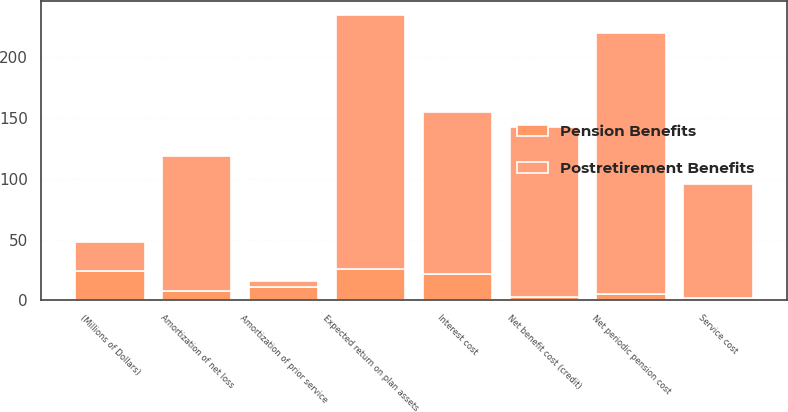Convert chart to OTSL. <chart><loc_0><loc_0><loc_500><loc_500><stacked_bar_chart><ecel><fcel>(Millions of Dollars)<fcel>Service cost<fcel>Interest cost<fcel>Expected return on plan assets<fcel>Amortization of prior service<fcel>Amortization of net loss<fcel>Net periodic pension cost<fcel>Net benefit cost (credit)<nl><fcel>Postretirement Benefits<fcel>24<fcel>94<fcel>133<fcel>209<fcel>5<fcel>111<fcel>215<fcel>140<nl><fcel>Pension Benefits<fcel>24<fcel>2<fcel>22<fcel>26<fcel>11<fcel>8<fcel>5<fcel>3<nl></chart> 